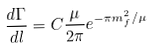Convert formula to latex. <formula><loc_0><loc_0><loc_500><loc_500>\frac { d \Gamma } { d l } = C \frac { \mu } { 2 \pi } e ^ { - \pi m _ { f } ^ { 2 } / \mu }</formula> 